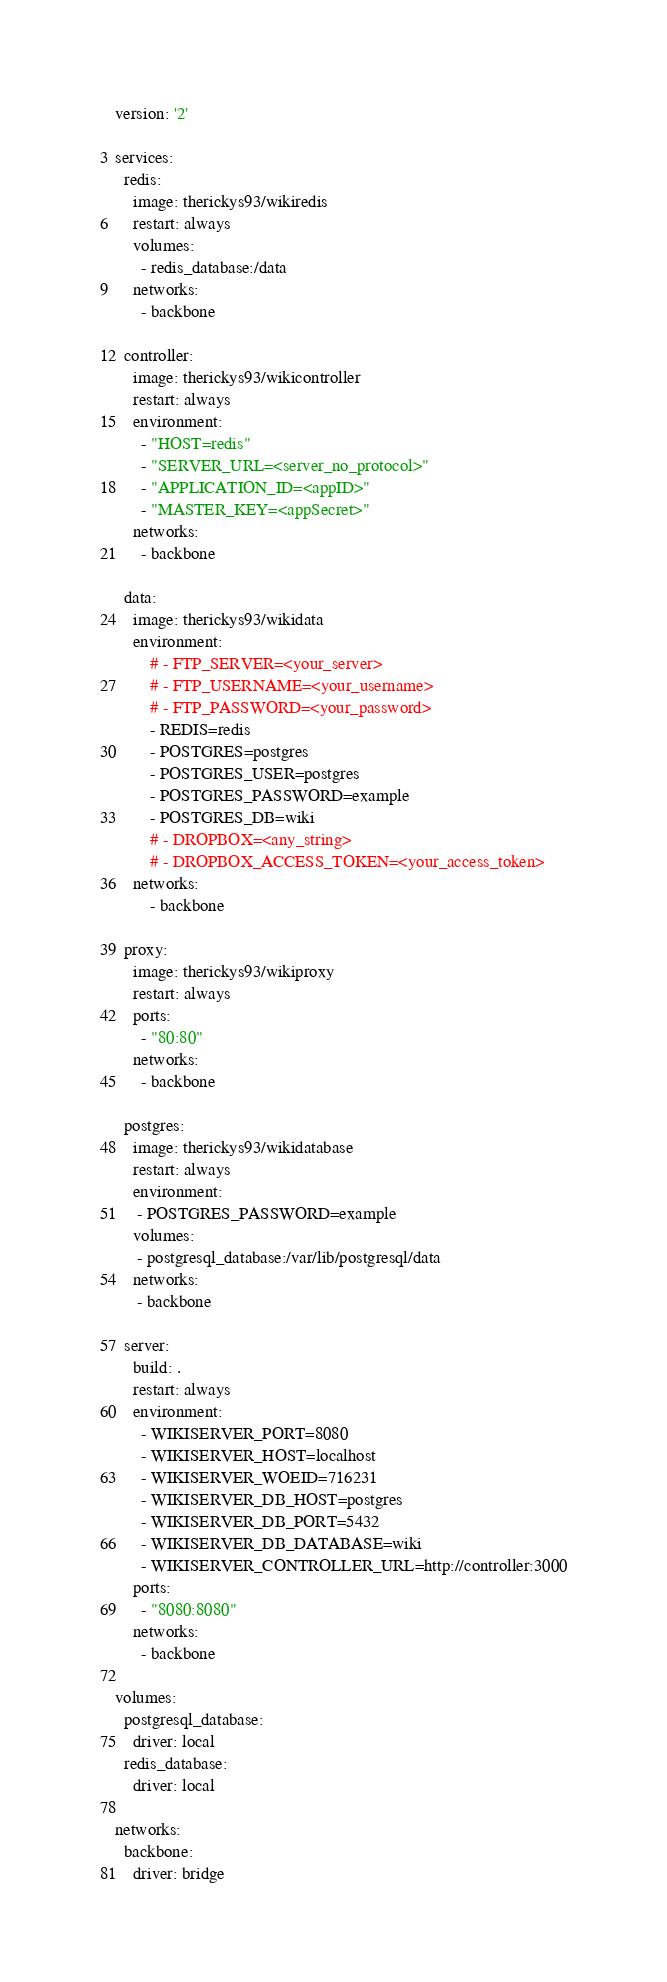Convert code to text. <code><loc_0><loc_0><loc_500><loc_500><_YAML_>version: '2'

services:
  redis:
    image: therickys93/wikiredis
    restart: always
    volumes:
      - redis_database:/data
    networks:
      - backbone

  controller:
    image: therickys93/wikicontroller
    restart: always
    environment:
      - "HOST=redis"
      - "SERVER_URL=<server_no_protocol>"
      - "APPLICATION_ID=<appID>"
      - "MASTER_KEY=<appSecret>"
    networks:
      - backbone

  data:
    image: therickys93/wikidata
    environment:
        # - FTP_SERVER=<your_server>
        # - FTP_USERNAME=<your_username>
        # - FTP_PASSWORD=<your_password>
        - REDIS=redis
        - POSTGRES=postgres
        - POSTGRES_USER=postgres
        - POSTGRES_PASSWORD=example
        - POSTGRES_DB=wiki
        # - DROPBOX=<any_string>
        # - DROPBOX_ACCESS_TOKEN=<your_access_token>
    networks: 
        - backbone

  proxy:
    image: therickys93/wikiproxy
    restart: always
    ports:
      - "80:80"
    networks:
      - backbone

  postgres:
    image: therickys93/wikidatabase
    restart: always
    environment:
     - POSTGRES_PASSWORD=example
    volumes:
     - postgresql_database:/var/lib/postgresql/data
    networks:
     - backbone

  server:
    build: .
    restart: always
    environment:
      - WIKISERVER_PORT=8080
      - WIKISERVER_HOST=localhost
      - WIKISERVER_WOEID=716231
      - WIKISERVER_DB_HOST=postgres
      - WIKISERVER_DB_PORT=5432
      - WIKISERVER_DB_DATABASE=wiki
      - WIKISERVER_CONTROLLER_URL=http://controller:3000
    ports:
      - "8080:8080"
    networks:
      - backbone

volumes:
  postgresql_database:
    driver: local
  redis_database:
    driver: local

networks:
  backbone:
    driver: bridge
</code> 